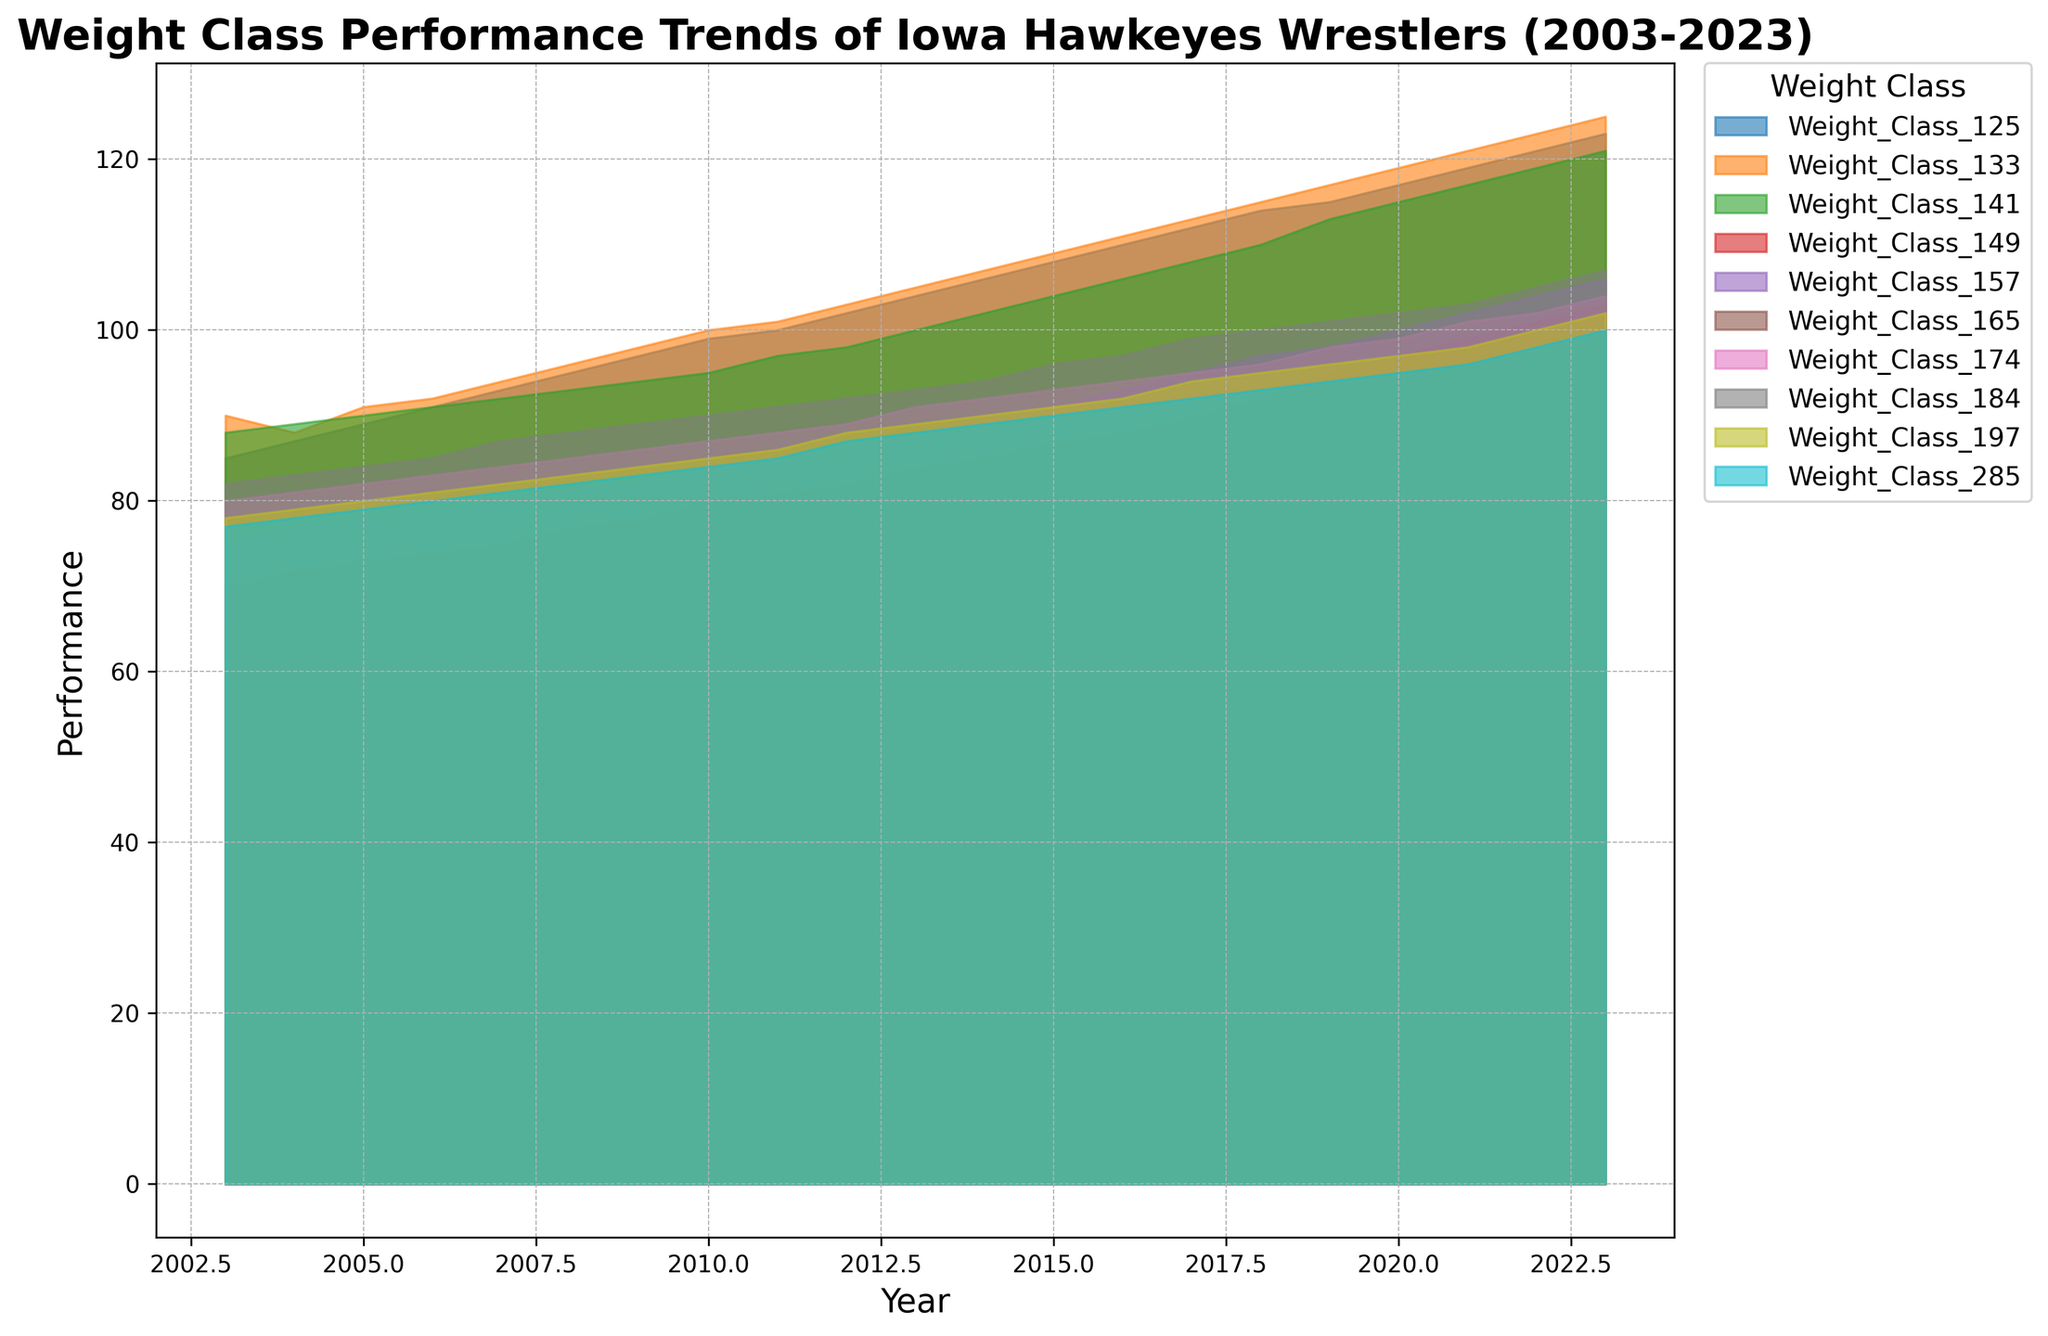Which weight class showed the largest improvement over the 20-year period? To determine which weight class showed the largest improvement, subtract the performance in 2003 from the performance in 2023 for each weight class. The class with the highest positive difference is the one with the largest improvement.
Answer: Weight Class 125 Which year did all weight classes have their lowest performance rates? To find the year when all weight classes were at their lowest, identify the year with the smallest area under the curve overall.
Answer: 2003 How did the performance of Weight Class 141 compare between 2010 and 2020? Check the values for Weight Class 141 in the years 2010 (95) and 2020 (115), and compare them.
Answer: Increased by 20 Which weight class had the most consistent performance over the years? A consistent performance means the values don't fluctuate much. By visually examining, Weight Class 133 remains relatively stable between 90 and 125 over the 20-year span.
Answer: Weight Class 133 Which weight classes had performance above 100 in 2023 but below 90 in 2003? Identify the weight classes with values above 100 in 2023 and below 90 in 2003. Weight Classes 125, 133, and 141 meet this criterion.
Answer: Weight Classes 125, 133, 141 In which year did Weight Class 165 first surpass the performance level of Weight Class 157? Compare the values of Weight Classes 165 and 157 across each year and find the first year where 165 is higher than 157. This first happens in 2014.
Answer: 2014 Which weight class had the highest performance in 2017? Find the weight class with the highest performance value in the year 2017 by visually inspecting the height of the areas. The highest point is for Weight Class 125 at 112.
Answer: Weight Class 125 What is the total performance sum for all weight classes in 2022? Add the performance values for all weight classes in the year 2022: 121 + 123 + 119 + 101 + 104 + 97 + 102 + 105 + 100 + 98 = 1070.
Answer: 1070 